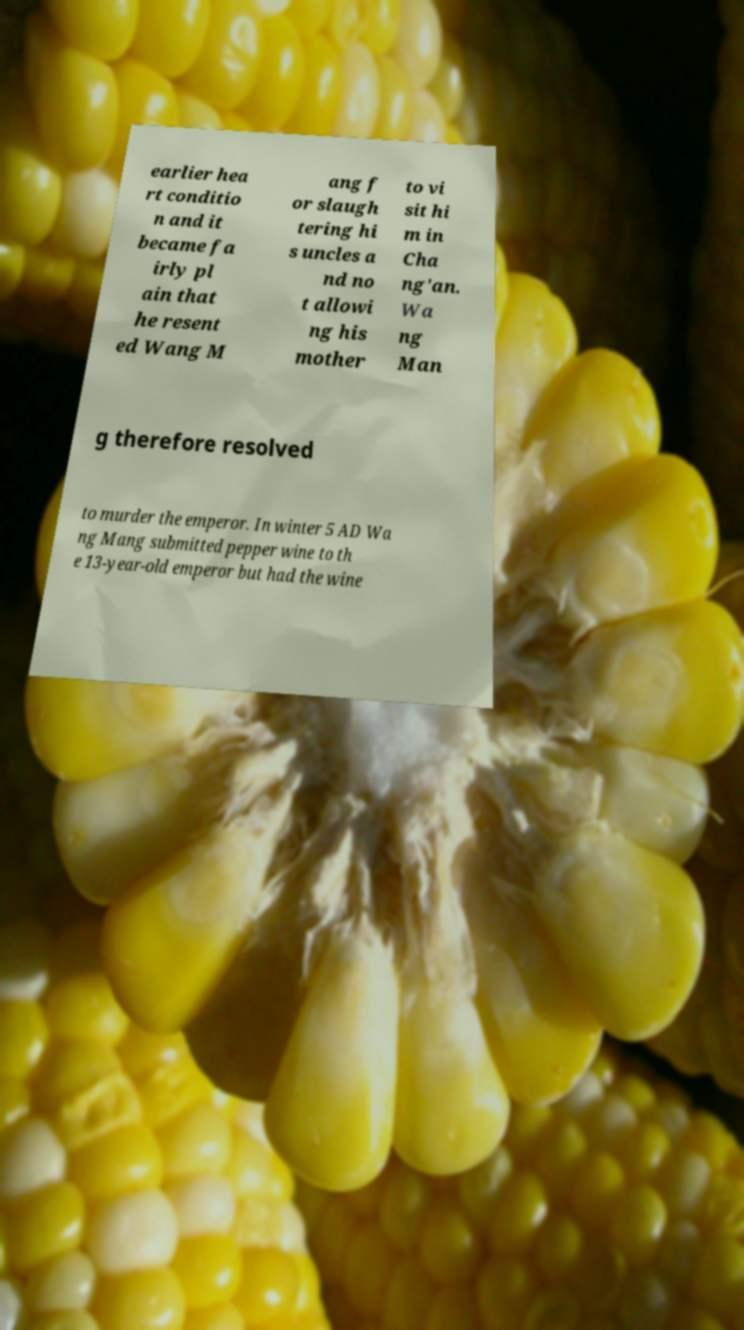For documentation purposes, I need the text within this image transcribed. Could you provide that? earlier hea rt conditio n and it became fa irly pl ain that he resent ed Wang M ang f or slaugh tering hi s uncles a nd no t allowi ng his mother to vi sit hi m in Cha ng'an. Wa ng Man g therefore resolved to murder the emperor. In winter 5 AD Wa ng Mang submitted pepper wine to th e 13-year-old emperor but had the wine 